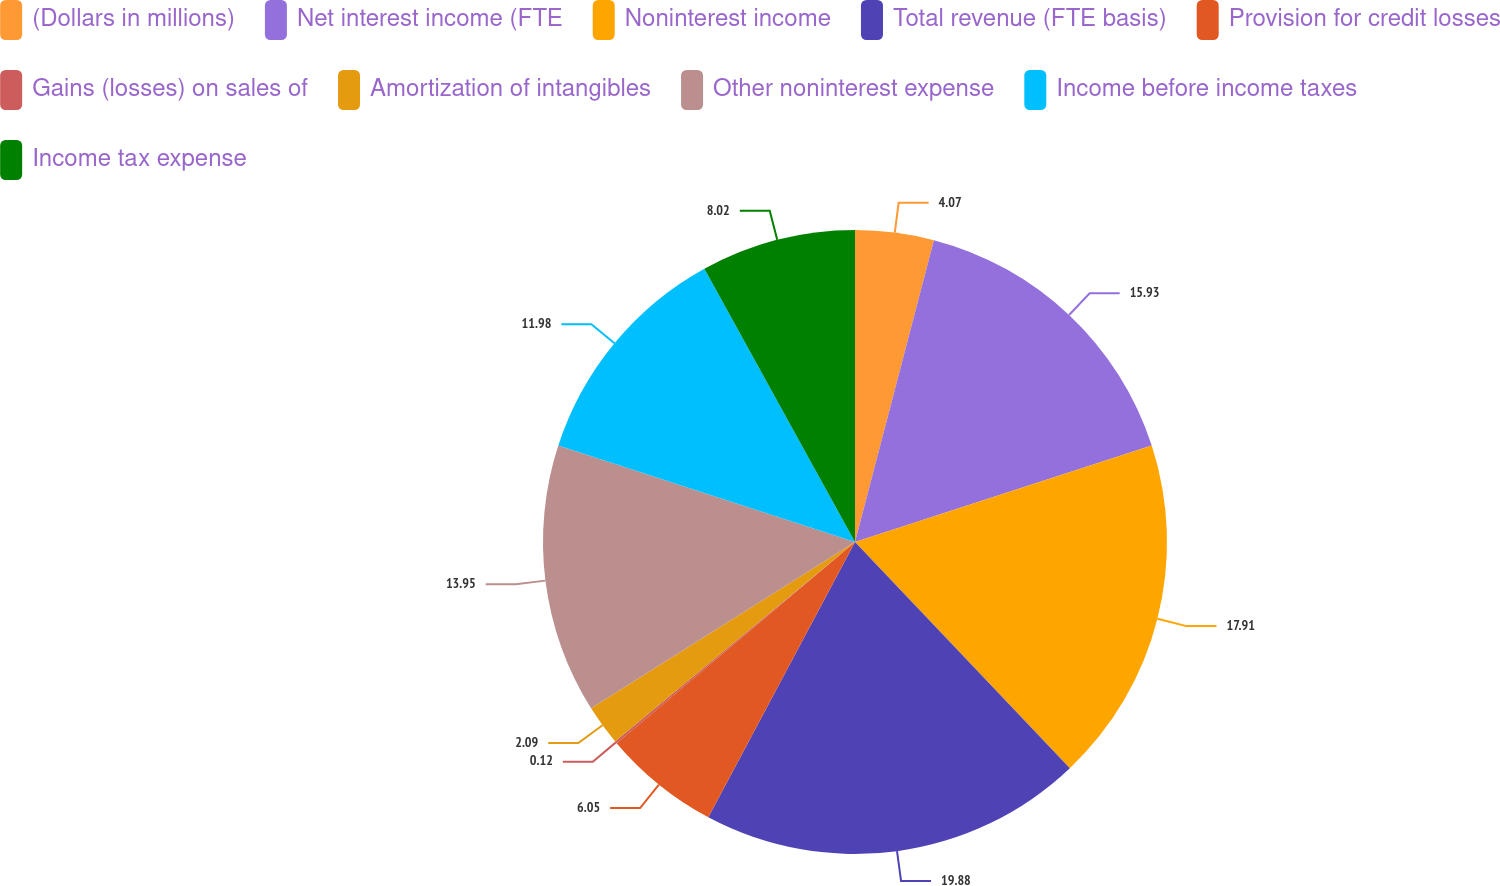Convert chart to OTSL. <chart><loc_0><loc_0><loc_500><loc_500><pie_chart><fcel>(Dollars in millions)<fcel>Net interest income (FTE<fcel>Noninterest income<fcel>Total revenue (FTE basis)<fcel>Provision for credit losses<fcel>Gains (losses) on sales of<fcel>Amortization of intangibles<fcel>Other noninterest expense<fcel>Income before income taxes<fcel>Income tax expense<nl><fcel>4.07%<fcel>15.93%<fcel>17.91%<fcel>19.88%<fcel>6.05%<fcel>0.12%<fcel>2.09%<fcel>13.95%<fcel>11.98%<fcel>8.02%<nl></chart> 